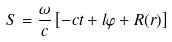Convert formula to latex. <formula><loc_0><loc_0><loc_500><loc_500>S = \frac { \omega } { c } \left [ - c t + l \varphi + R ( r ) \right ]</formula> 